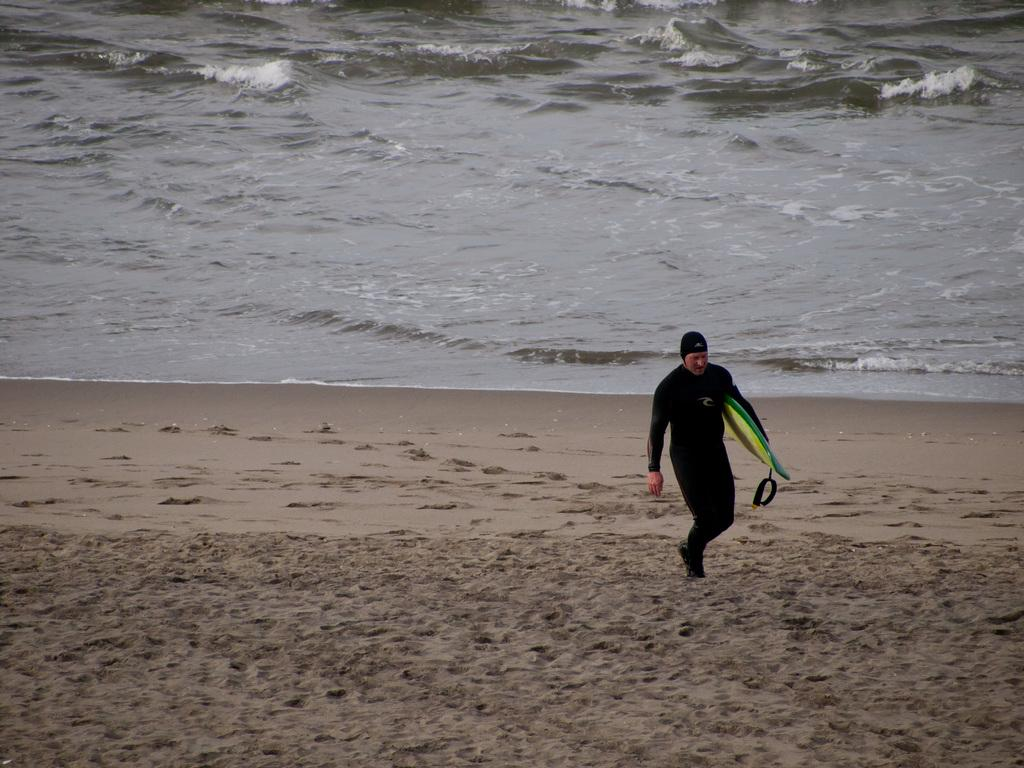Who is present in the image? There is a man in the image. What is the man wearing? The man is wearing a black dress. What object is the man holding? The man is holding a skateboard. Where is the man located in the image? The man is standing on the beach. What can be seen in the background of the image? There is water visible at the top of the image. How many members of the family are visible in the image? There is no family present in the image; it only features a man. What type of lumber is being used to construct the skateboard in the image? There is no lumber visible in the image, as the focus is on the man holding a skateboard, not the construction of the skateboard. 